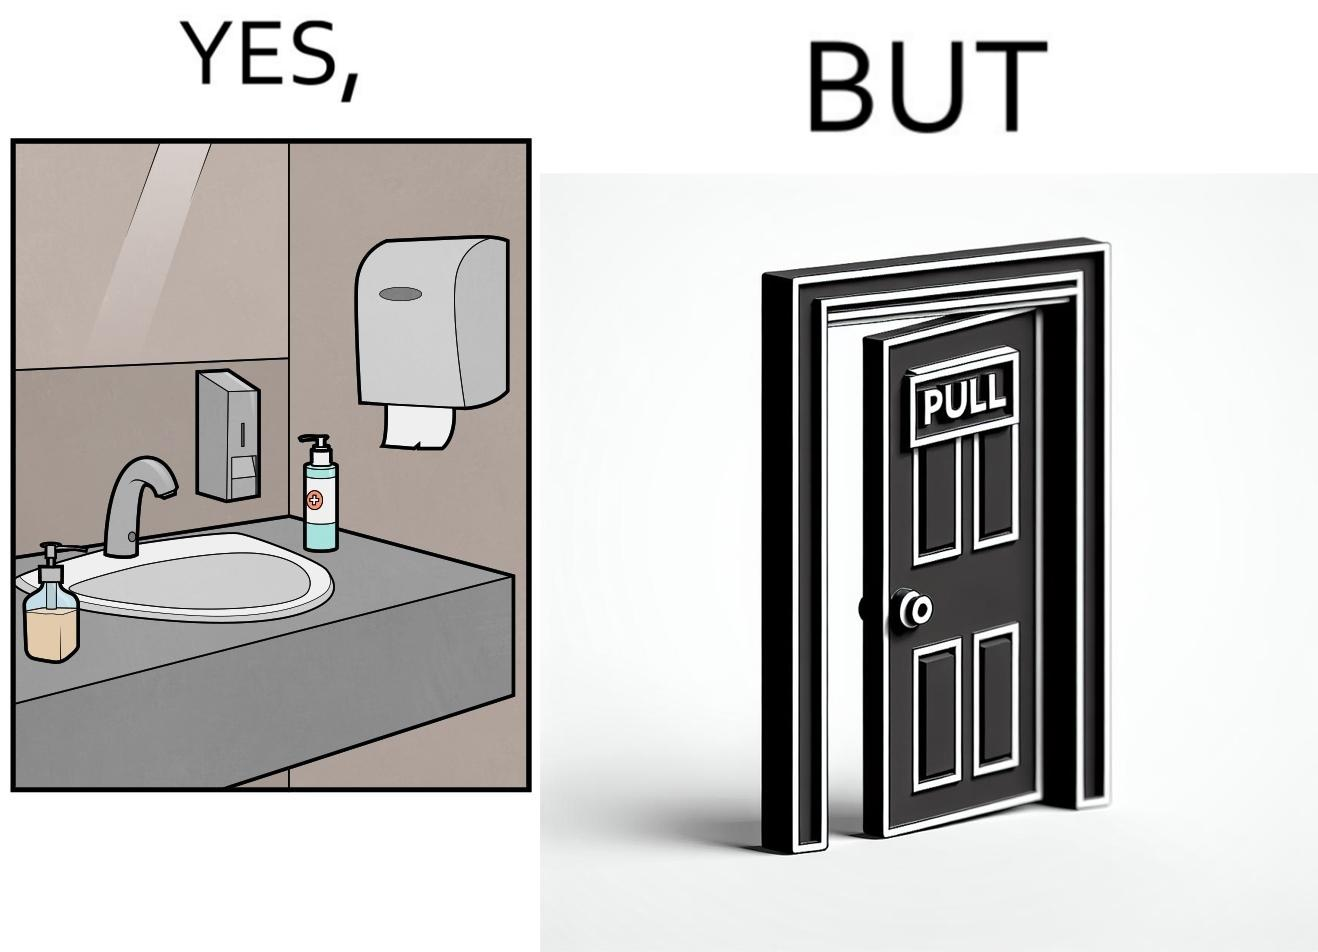Is this a satirical image? Yes, this image is satirical. 